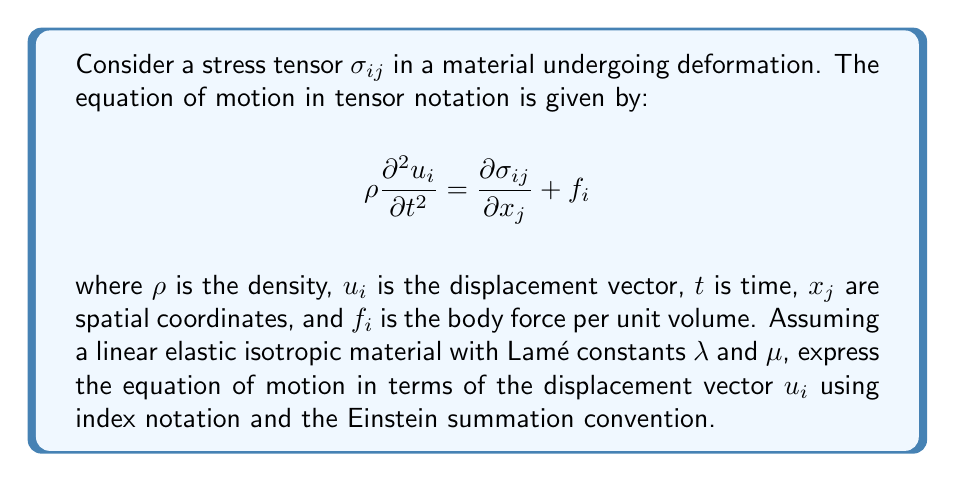Could you help me with this problem? Let's approach this step-by-step:

1) For a linear elastic isotropic material, the stress-strain relationship is given by:

   $$\sigma_{ij} = \lambda \epsilon_{kk} \delta_{ij} + 2\mu \epsilon_{ij}$$

   where $\epsilon_{ij}$ is the strain tensor and $\delta_{ij}$ is the Kronecker delta.

2) The strain-displacement relationship in index notation is:

   $$\epsilon_{ij} = \frac{1}{2}\left(\frac{\partial u_i}{\partial x_j} + \frac{\partial u_j}{\partial x_i}\right)$$

3) Substituting this into the stress-strain relationship:

   $$\sigma_{ij} = \lambda \frac{\partial u_k}{\partial x_k} \delta_{ij} + \mu\left(\frac{\partial u_i}{\partial x_j} + \frac{\partial u_j}{\partial x_i}\right)$$

4) Now, we need to calculate $\frac{\partial \sigma_{ij}}{\partial x_j}$:

   $$\frac{\partial \sigma_{ij}}{\partial x_j} = \lambda \frac{\partial^2 u_k}{\partial x_j \partial x_k} \delta_{ij} + \mu\left(\frac{\partial^2 u_i}{\partial x_j \partial x_j} + \frac{\partial^2 u_j}{\partial x_i \partial x_j}\right)$$

5) Simplify using properties of $\delta_{ij}$ and the fact that partial derivatives commute:

   $$\frac{\partial \sigma_{ij}}{\partial x_j} = \lambda \frac{\partial^2 u_k}{\partial x_k \partial x_i} + \mu\frac{\partial^2 u_i}{\partial x_j \partial x_j} + \mu\frac{\partial^2 u_j}{\partial x_i \partial x_j}$$

6) The last term can be rewritten as:

   $$\frac{\partial \sigma_{ij}}{\partial x_j} = \lambda \frac{\partial^2 u_k}{\partial x_k \partial x_i} + \mu\frac{\partial^2 u_i}{\partial x_j \partial x_j} + \mu\frac{\partial}{\partial x_i}\left(\frac{\partial u_j}{\partial x_j}\right)$$

7) Substituting this back into the equation of motion:

   $$\rho \frac{\partial^2 u_i}{\partial t^2} = \lambda \frac{\partial^2 u_k}{\partial x_k \partial x_i} + \mu\frac{\partial^2 u_i}{\partial x_j \partial x_j} + \mu\frac{\partial}{\partial x_i}\left(\frac{\partial u_j}{\partial x_j}\right) + f_i$$

8) Rearranging terms:

   $$\rho \frac{\partial^2 u_i}{\partial t^2} = (\lambda + \mu)\frac{\partial}{\partial x_i}\left(\frac{\partial u_j}{\partial x_j}\right) + \mu\frac{\partial^2 u_i}{\partial x_j \partial x_j} + f_i$$

This is the final form of the equation of motion in terms of the displacement vector $u_i$.
Answer: $$\rho \frac{\partial^2 u_i}{\partial t^2} = (\lambda + \mu)\frac{\partial}{\partial x_i}\left(\frac{\partial u_j}{\partial x_j}\right) + \mu\frac{\partial^2 u_i}{\partial x_j \partial x_j} + f_i$$ 